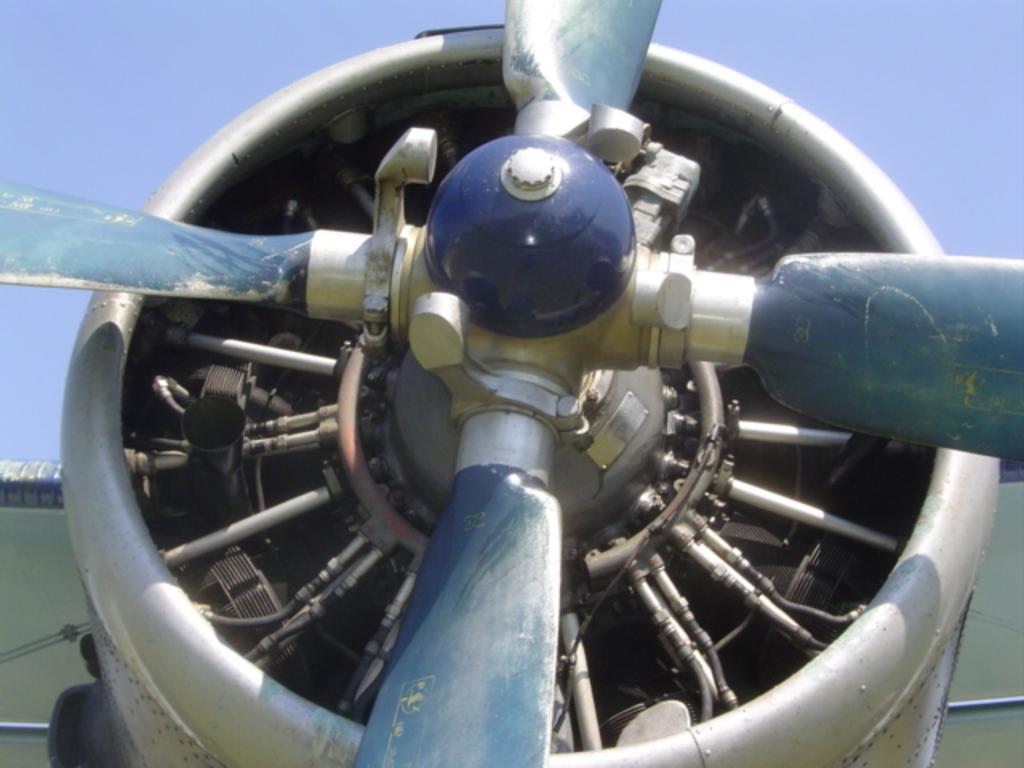Please provide a concise description of this image. This is the picture of a object to which there are some wings and some other objects. 